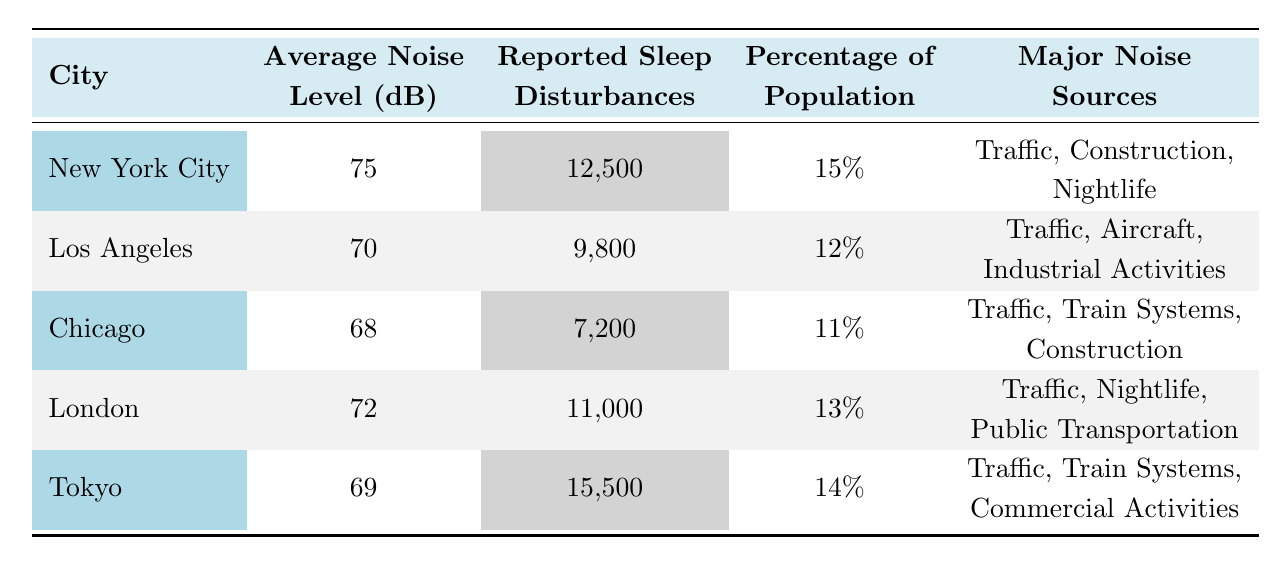What is the average noise level in New York City? The table states that the average noise level for New York City is listed as 75 dB.
Answer: 75 dB Which city has the highest number of reported sleep disturbances? By comparing the reported cases across the cities, Tokyo has 15,500 cases, which is higher than any other city listed.
Answer: Tokyo What percentage of the population in Chicago reported sleep disturbances? The table indicates that in Chicago, the percentage of the population reporting sleep disturbances is 11%.
Answer: 11% Is there any city where traffic is not a major noise source? Looking at the table, all cities listed have traffic as a major noise source. Therefore, the answer is no.
Answer: No Which city has the lowest average noise level, and what is that level? The average noise levels for each city are compared, and Chicago has the lowest level at 68 dB.
Answer: Chicago, 68 dB What is the total number of reported sleep disturbances for both Los Angeles and London? Adding the reported cases for Los Angeles (9,800) and London (11,000) gives 20,800.
Answer: 20,800 What is the difference in average noise levels between New York City and Tokyo? The average noise level in New York City is 75 dB and in Tokyo, it is 69 dB. The difference is 75 - 69 = 6 dB.
Answer: 6 dB Which city has the highest percentage of reported sleep disturbances and what is that percentage? Comparing the percentages, New York City has the highest at 15%.
Answer: New York City, 15% Which areas are most affected by sleep disturbances in Chicago? The table lists the most affected areas in Chicago as The Loop, River North, and Wrigleyville.
Answer: The Loop, River North, Wrigleyville What is the average reported sleep disturbances among the cities listed? The average is calculated by adding all reported cases (12,500 + 9,800 + 7,200 + 11,000 + 15,500 = 55,000) and dividing by the number of cities (5), giving an average of 11,000.
Answer: 11,000 Are reported sleep disturbances higher in Tokyo compared to Los Angeles? Comparing the reported cases, Tokyo has 15,500 cases, while Los Angeles has 9,800, indicating that Tokyo has higher reported disturbances.
Answer: Yes 